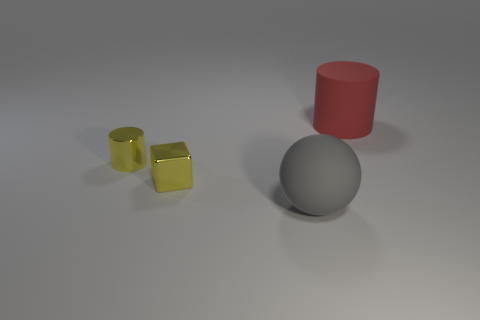Add 2 small cyan metal spheres. How many objects exist? 6 Subtract all cubes. How many objects are left? 3 Subtract 0 gray blocks. How many objects are left? 4 Subtract all gray cylinders. Subtract all shiny cylinders. How many objects are left? 3 Add 3 gray matte objects. How many gray matte objects are left? 4 Add 2 big green matte balls. How many big green matte balls exist? 2 